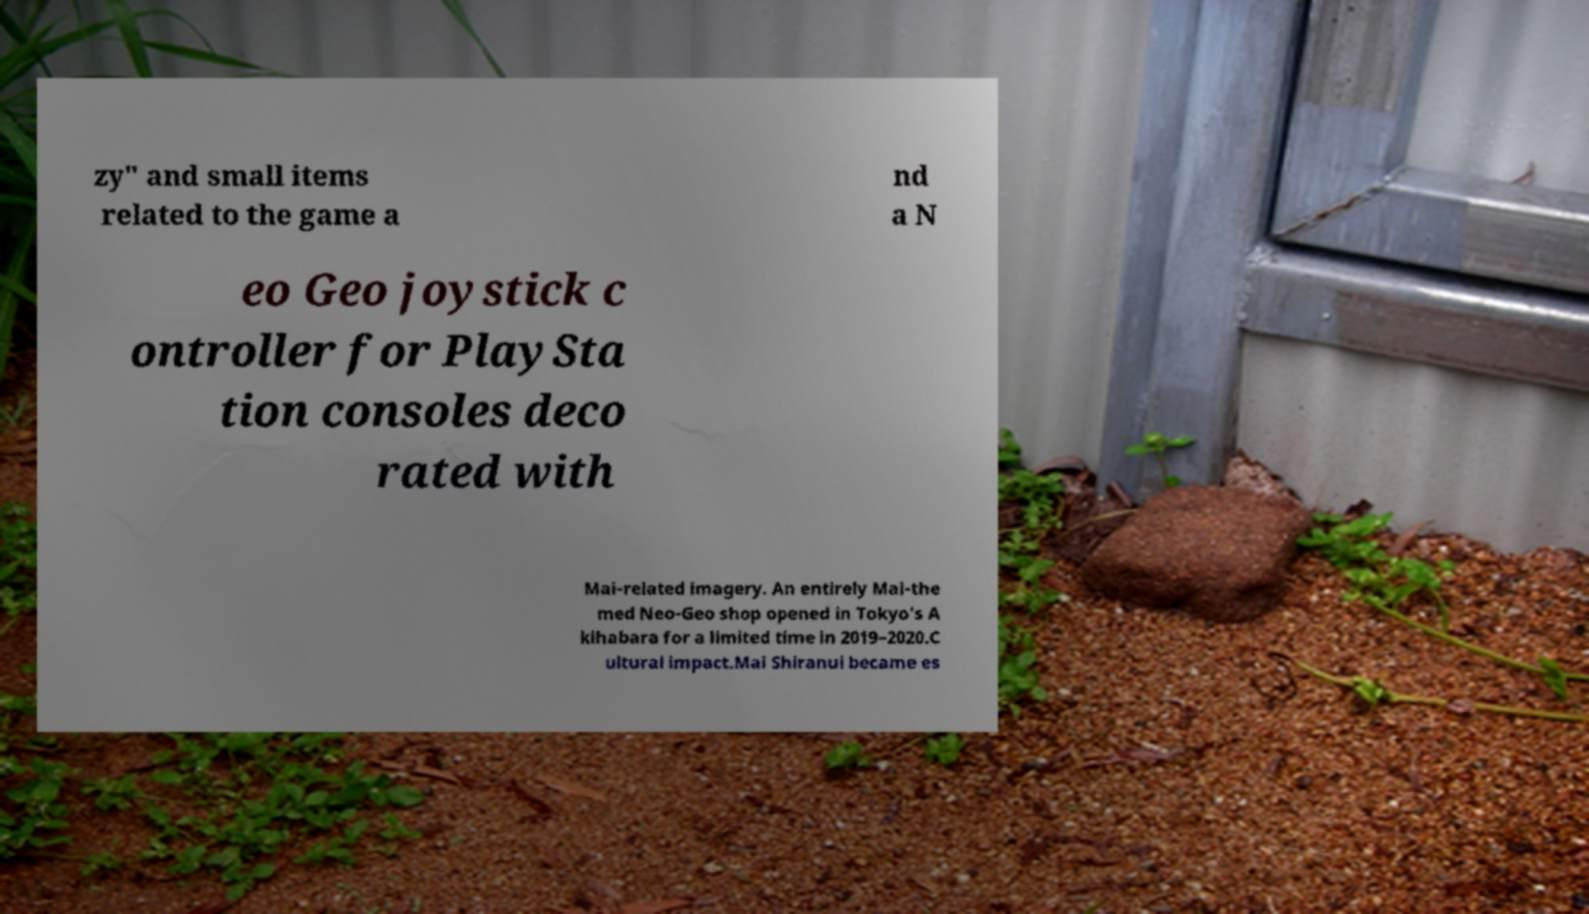Please read and relay the text visible in this image. What does it say? zy" and small items related to the game a nd a N eo Geo joystick c ontroller for PlaySta tion consoles deco rated with Mai-related imagery. An entirely Mai-the med Neo-Geo shop opened in Tokyo's A kihabara for a limited time in 2019–2020.C ultural impact.Mai Shiranui became es 